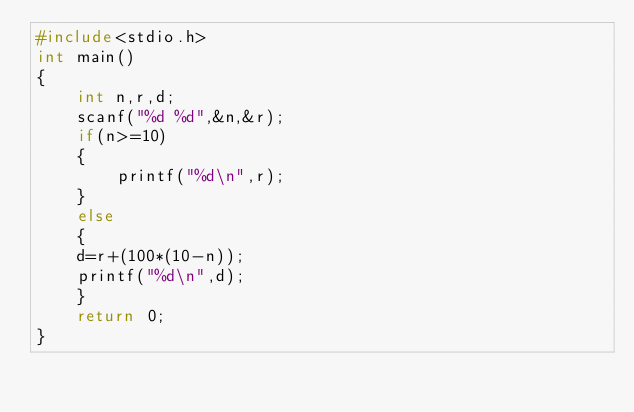<code> <loc_0><loc_0><loc_500><loc_500><_C_>#include<stdio.h>
int main()
{
    int n,r,d;
    scanf("%d %d",&n,&r);
    if(n>=10)
    {
        printf("%d\n",r);
    }
    else
    {
    d=r+(100*(10-n));
    printf("%d\n",d);
    }
    return 0;
}</code> 